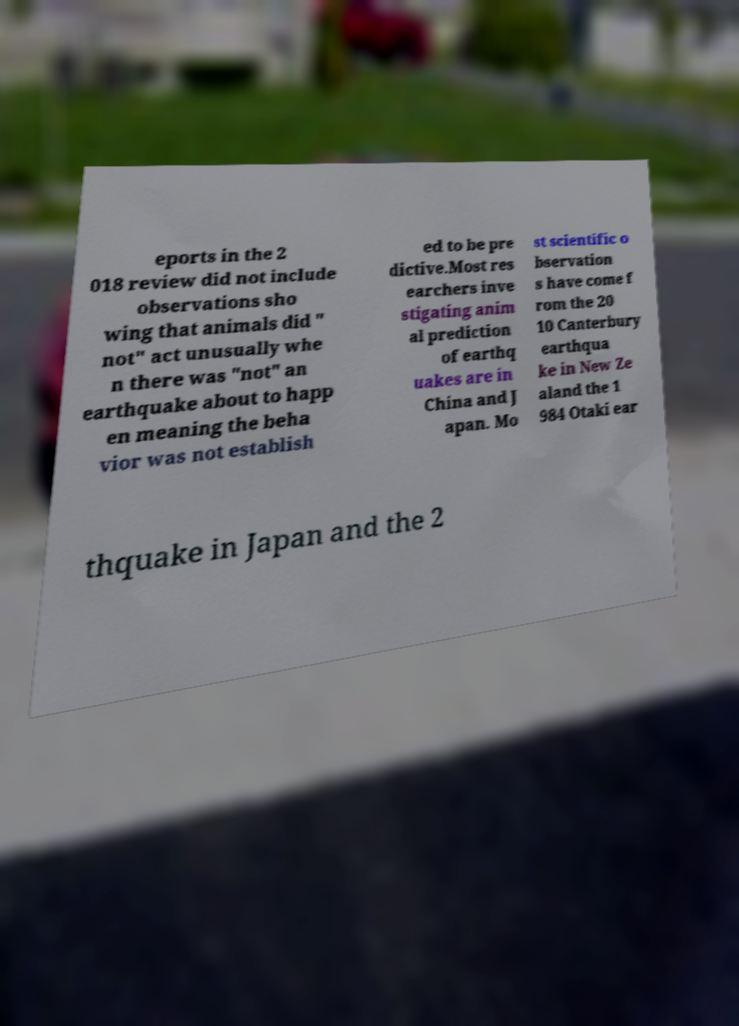Could you assist in decoding the text presented in this image and type it out clearly? eports in the 2 018 review did not include observations sho wing that animals did " not" act unusually whe n there was "not" an earthquake about to happ en meaning the beha vior was not establish ed to be pre dictive.Most res earchers inve stigating anim al prediction of earthq uakes are in China and J apan. Mo st scientific o bservation s have come f rom the 20 10 Canterbury earthqua ke in New Ze aland the 1 984 Otaki ear thquake in Japan and the 2 